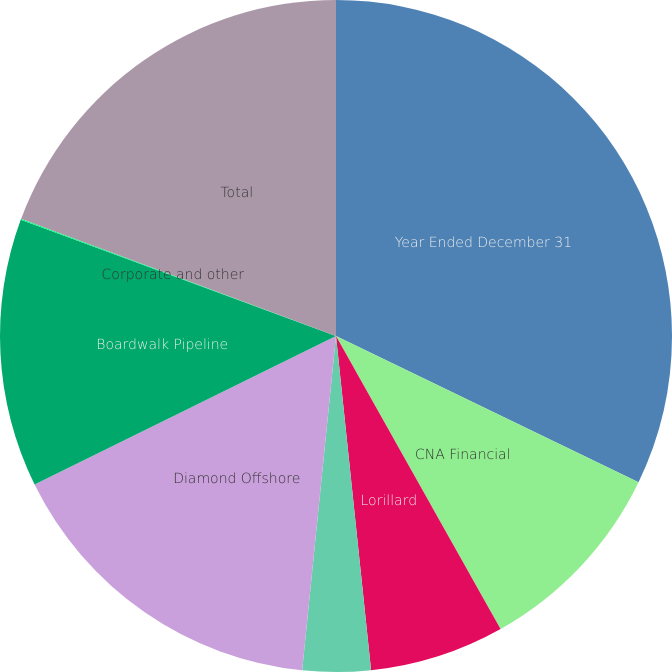Convert chart. <chart><loc_0><loc_0><loc_500><loc_500><pie_chart><fcel>Year Ended December 31<fcel>CNA Financial<fcel>Lorillard<fcel>Loews Hotels<fcel>Diamond Offshore<fcel>Boardwalk Pipeline<fcel>Corporate and other<fcel>Total<nl><fcel>32.16%<fcel>9.69%<fcel>6.48%<fcel>3.27%<fcel>16.11%<fcel>12.9%<fcel>0.06%<fcel>19.32%<nl></chart> 